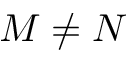<formula> <loc_0><loc_0><loc_500><loc_500>M \ne N</formula> 